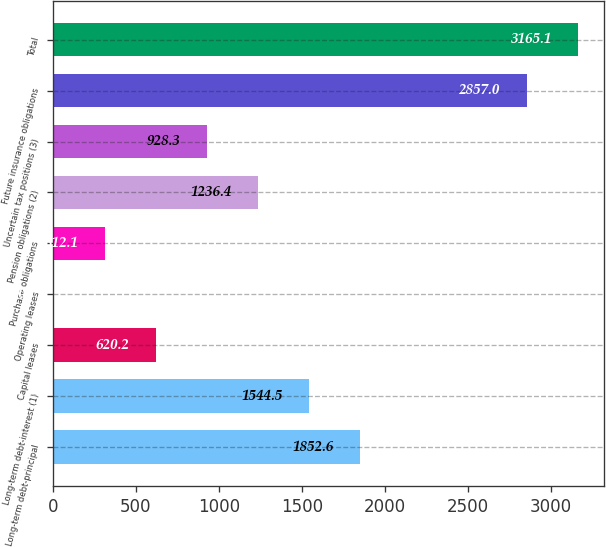Convert chart. <chart><loc_0><loc_0><loc_500><loc_500><bar_chart><fcel>Long-term debt-principal<fcel>Long-term debt-interest (1)<fcel>Capital leases<fcel>Operating leases<fcel>Purchase obligations<fcel>Pension obligations (2)<fcel>Uncertain tax positions (3)<fcel>Future insurance obligations<fcel>Total<nl><fcel>1852.6<fcel>1544.5<fcel>620.2<fcel>4<fcel>312.1<fcel>1236.4<fcel>928.3<fcel>2857<fcel>3165.1<nl></chart> 